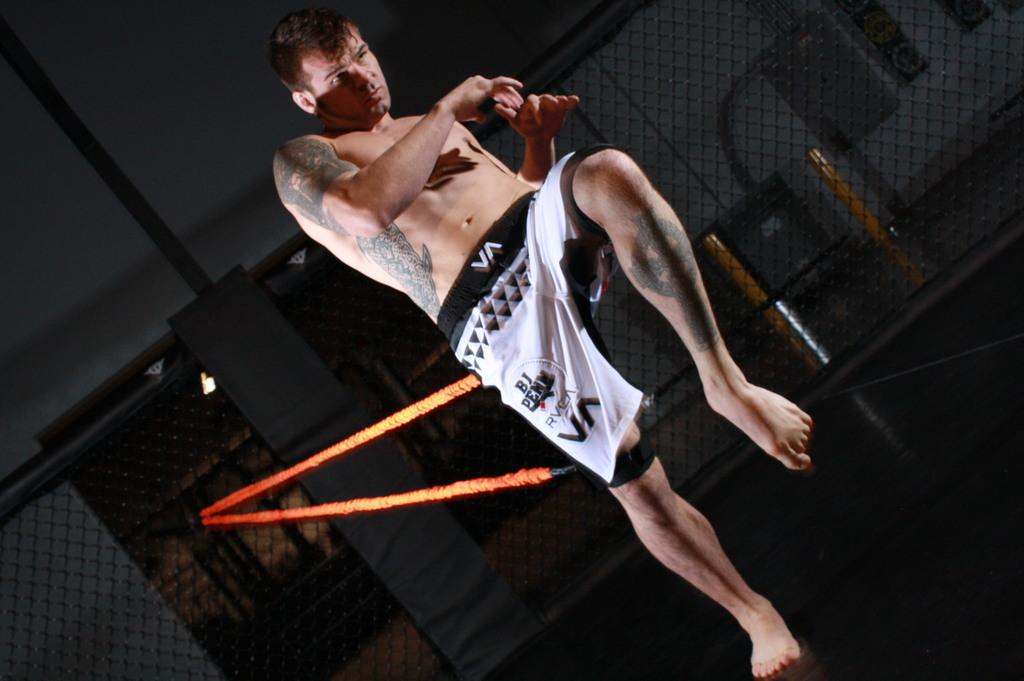<image>
Render a clear and concise summary of the photo. A martial arts practitioner with VA printed on his shorts. 